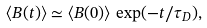Convert formula to latex. <formula><loc_0><loc_0><loc_500><loc_500>\langle B ( t ) \rangle \simeq \langle B ( 0 ) \rangle \, \exp ( - t / \tau _ { D } ) ,</formula> 